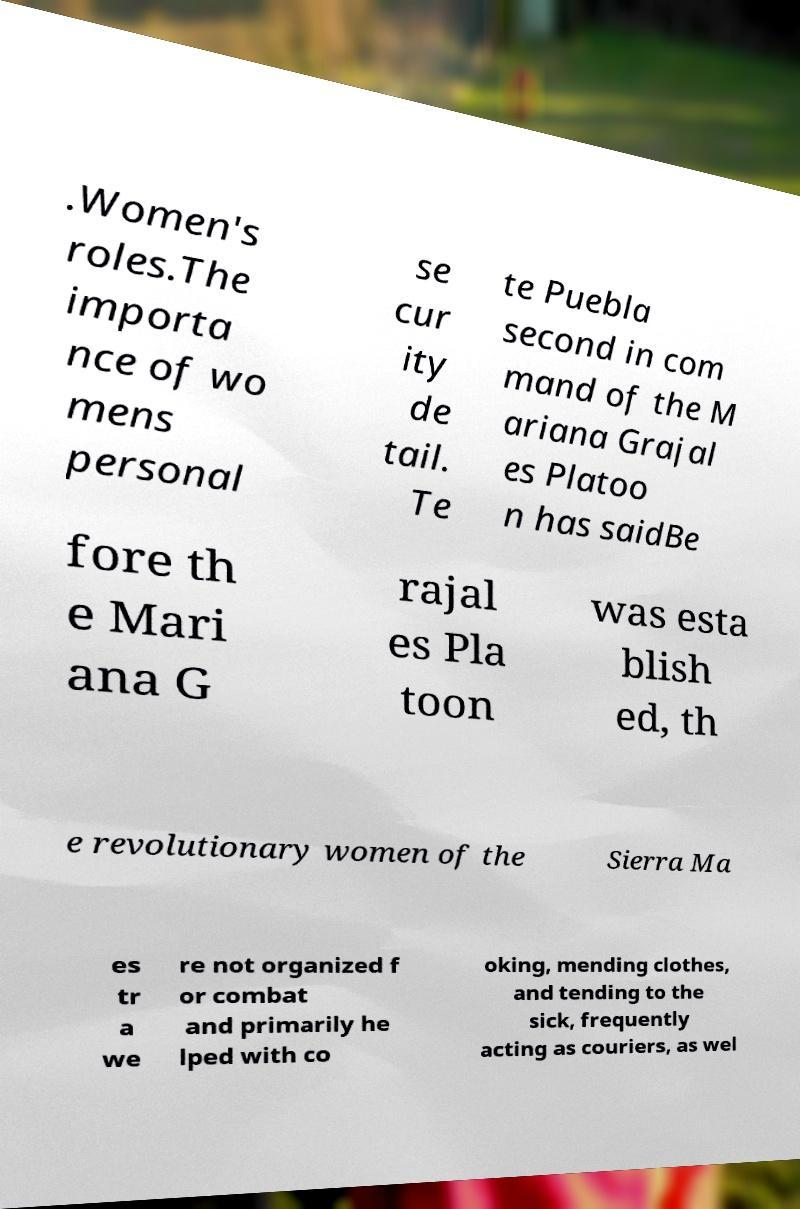Can you accurately transcribe the text from the provided image for me? .Women's roles.The importa nce of wo mens personal se cur ity de tail. Te te Puebla second in com mand of the M ariana Grajal es Platoo n has saidBe fore th e Mari ana G rajal es Pla toon was esta blish ed, th e revolutionary women of the Sierra Ma es tr a we re not organized f or combat and primarily he lped with co oking, mending clothes, and tending to the sick, frequently acting as couriers, as wel 